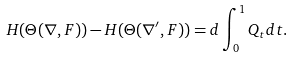Convert formula to latex. <formula><loc_0><loc_0><loc_500><loc_500>H ( \Theta ( \nabla , F ) ) - H ( \Theta ( \nabla ^ { \prime } , F ) ) = d \int ^ { 1 } _ { 0 } Q _ { t } d t .</formula> 